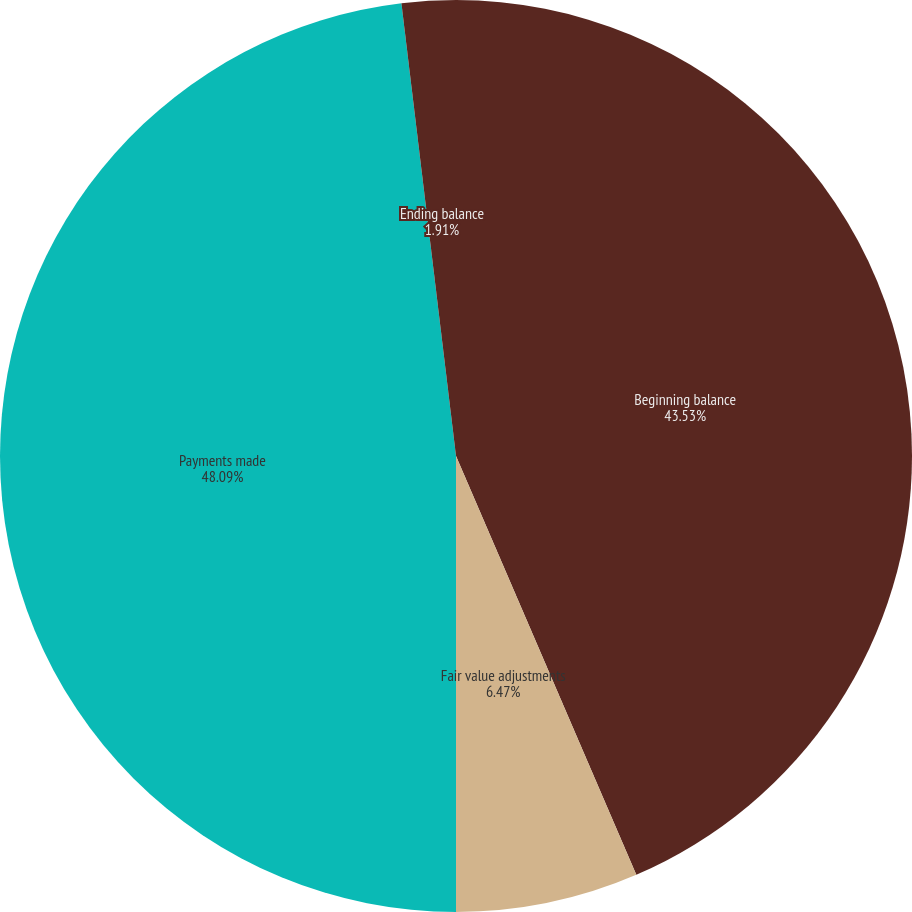Convert chart. <chart><loc_0><loc_0><loc_500><loc_500><pie_chart><fcel>Beginning balance<fcel>Fair value adjustments<fcel>Payments made<fcel>Ending balance<nl><fcel>43.53%<fcel>6.47%<fcel>48.09%<fcel>1.91%<nl></chart> 